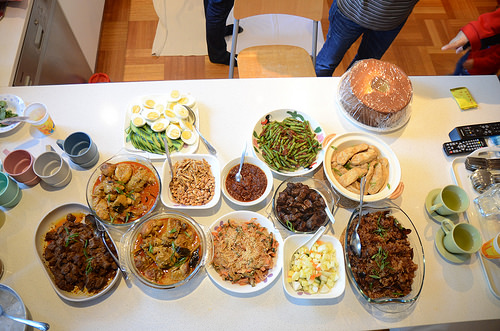<image>
Can you confirm if the green beans is to the left of the deviled eggs? No. The green beans is not to the left of the deviled eggs. From this viewpoint, they have a different horizontal relationship. 